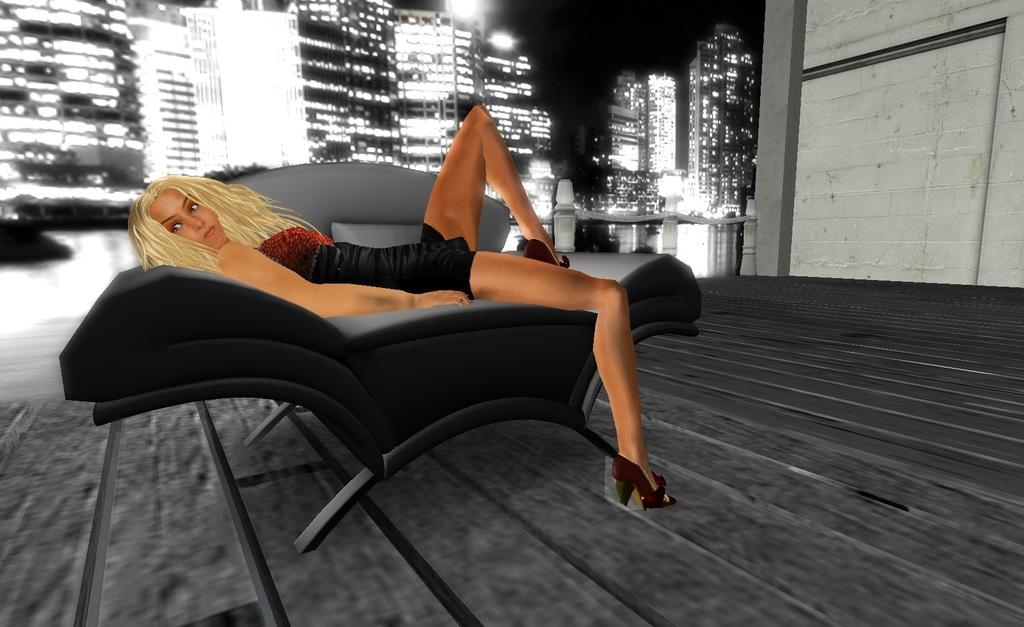Who is present in the image? There is a woman in the image. What is the woman doing in the image? The woman is laying on a sofa. What can be seen in the background of the image? There are buildings, lights, and a wall in the background of the image. Are there any lizards crawling on the silk fabric in the image? There is no silk fabric or lizards present in the image. 